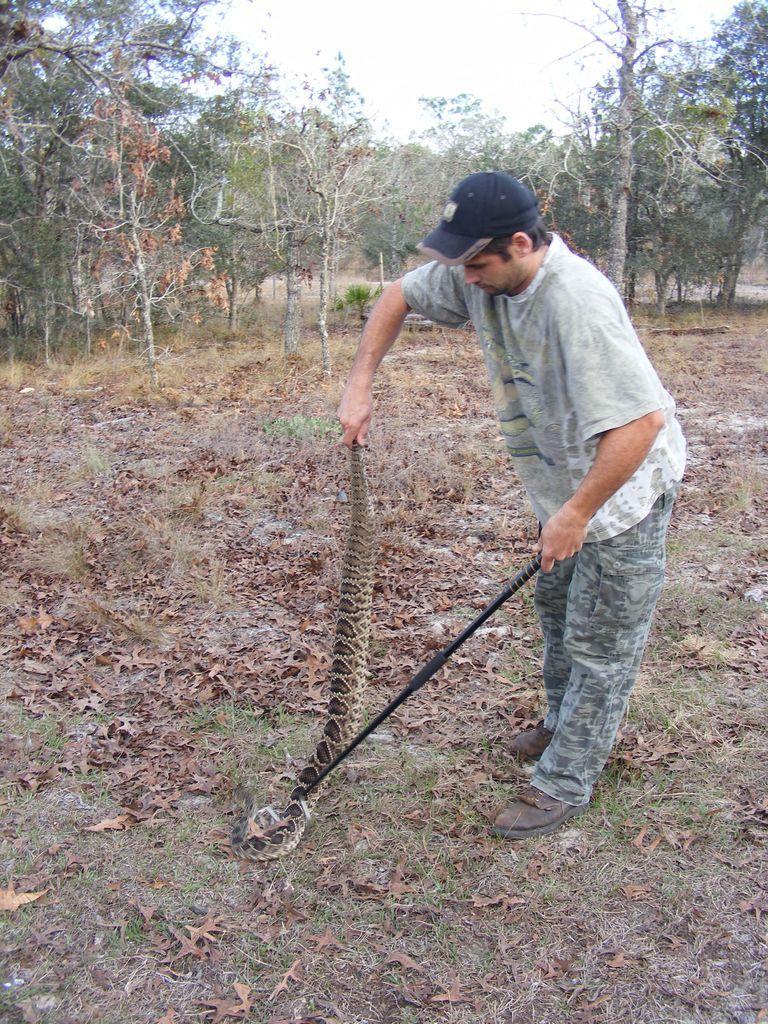In one or two sentences, can you explain what this image depicts? In this image we can see a person holding a snake, and a stick, there are trees, leaves on the ground, also we can see the sky. 